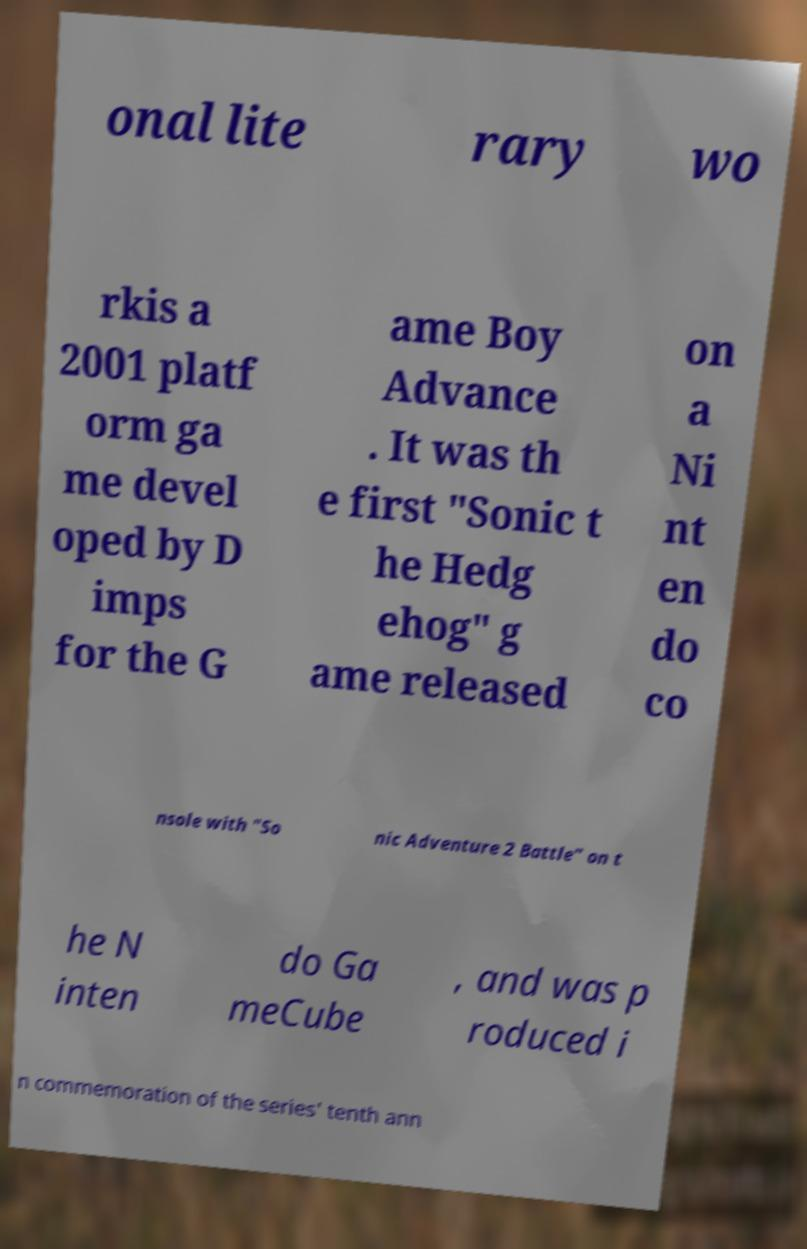What messages or text are displayed in this image? I need them in a readable, typed format. onal lite rary wo rkis a 2001 platf orm ga me devel oped by D imps for the G ame Boy Advance . It was th e first "Sonic t he Hedg ehog" g ame released on a Ni nt en do co nsole with "So nic Adventure 2 Battle" on t he N inten do Ga meCube , and was p roduced i n commemoration of the series' tenth ann 